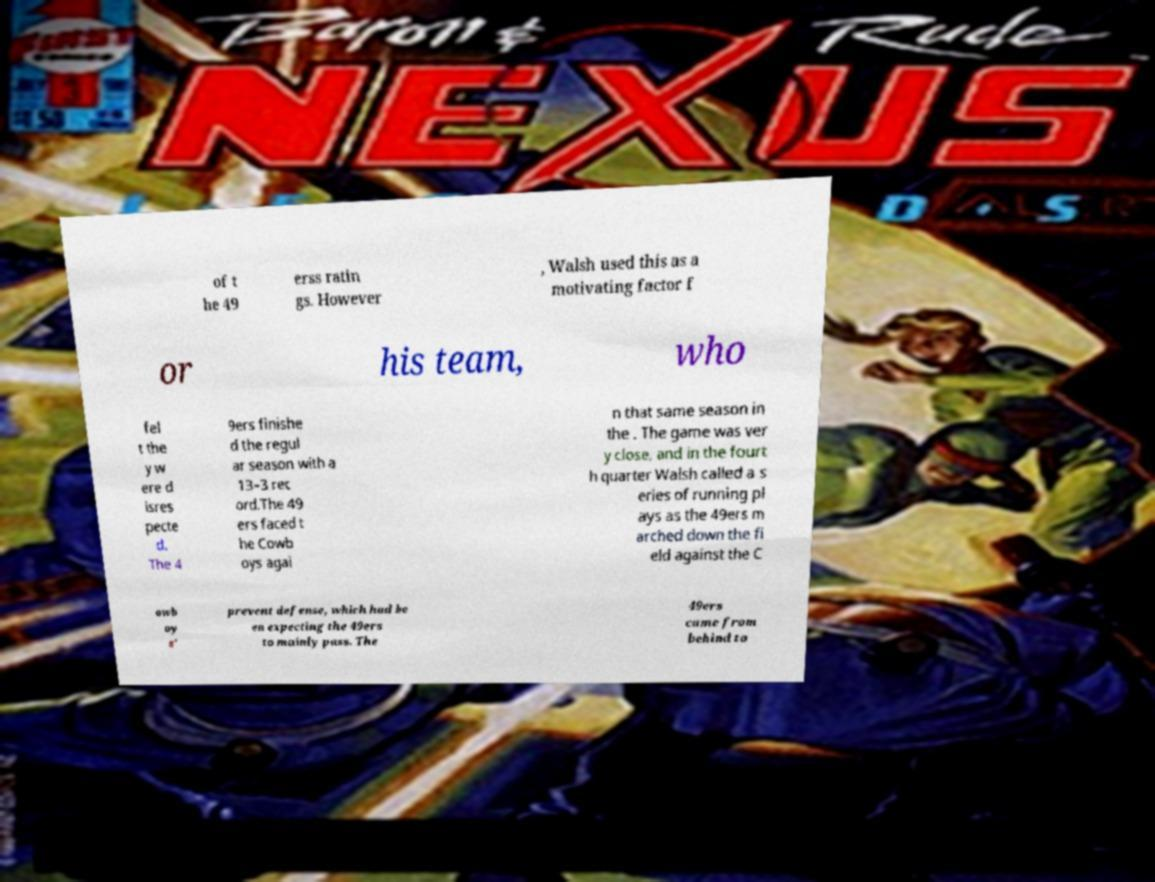Could you extract and type out the text from this image? of t he 49 erss ratin gs. However , Walsh used this as a motivating factor f or his team, who fel t the y w ere d isres pecte d. The 4 9ers finishe d the regul ar season with a 13–3 rec ord.The 49 ers faced t he Cowb oys agai n that same season in the . The game was ver y close, and in the fourt h quarter Walsh called a s eries of running pl ays as the 49ers m arched down the fi eld against the C owb oy s' prevent defense, which had be en expecting the 49ers to mainly pass. The 49ers came from behind to 